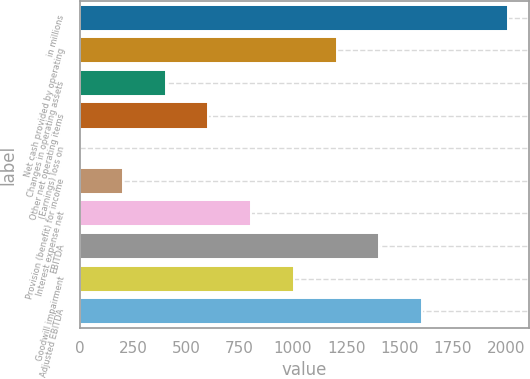Convert chart to OTSL. <chart><loc_0><loc_0><loc_500><loc_500><bar_chart><fcel>in millions<fcel>Net cash provided by operating<fcel>Changes in operating assets<fcel>Other net operating items<fcel>(Earnings) loss on<fcel>Provision (benefit) for income<fcel>Interest expense net<fcel>EBITDA<fcel>Goodwill impairment<fcel>Adjusted EBITDA<nl><fcel>2008<fcel>1205.76<fcel>403.52<fcel>604.08<fcel>2.4<fcel>202.96<fcel>804.64<fcel>1406.32<fcel>1005.2<fcel>1606.88<nl></chart> 